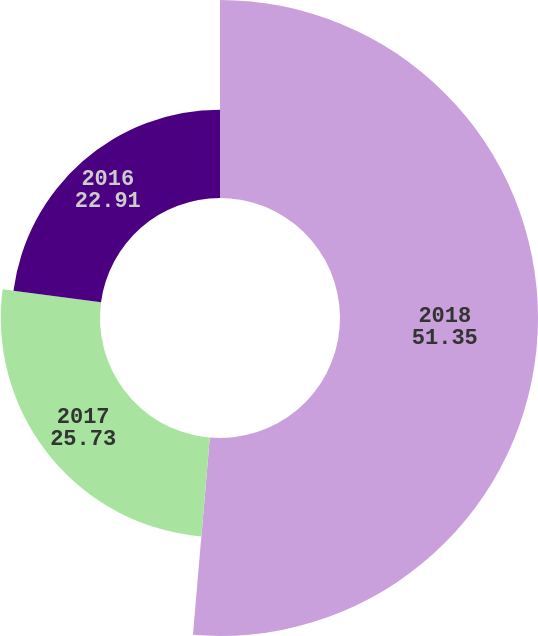Convert chart. <chart><loc_0><loc_0><loc_500><loc_500><pie_chart><fcel>2018<fcel>2017<fcel>2016<nl><fcel>51.35%<fcel>25.73%<fcel>22.91%<nl></chart> 